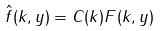Convert formula to latex. <formula><loc_0><loc_0><loc_500><loc_500>\hat { f } ( k , y ) = C ( k ) F ( k , y )</formula> 